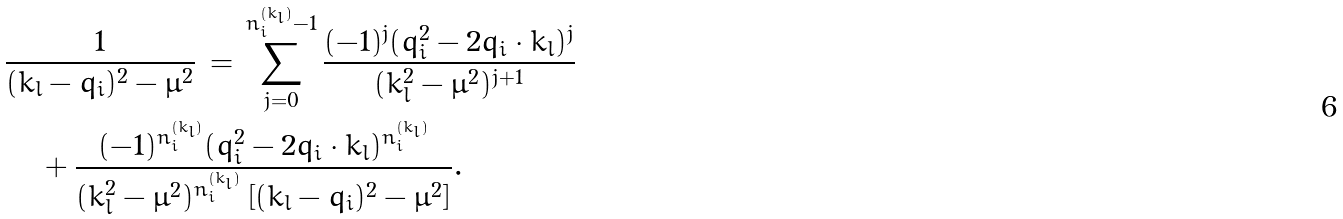Convert formula to latex. <formula><loc_0><loc_0><loc_500><loc_500>& \frac { 1 } { ( k _ { l } - q _ { i } ) ^ { 2 } - \mu ^ { 2 } } \, = \, \sum _ { j = 0 } ^ { n _ { i } ^ { ( k _ { l } ) } - 1 } \frac { ( - 1 ) ^ { j } ( q _ { i } ^ { 2 } - 2 q _ { i } \cdot k _ { l } ) ^ { j } } { ( k _ { l } ^ { 2 } - \mu ^ { 2 } ) ^ { j + 1 } } \quad \\ & \quad \, + \frac { ( - 1 ) ^ { n _ { i } ^ { ( k _ { l } ) } } ( q _ { i } ^ { 2 } - 2 q _ { i } \cdot k _ { l } ) ^ { n _ { i } ^ { ( k _ { l } ) } } } { ( k _ { l } ^ { 2 } - \mu ^ { 2 } ) ^ { n _ { i } ^ { ( k _ { l } ) } } \left [ ( k _ { l } - q _ { i } ) ^ { 2 } - \mu ^ { 2 } \right ] } .</formula> 